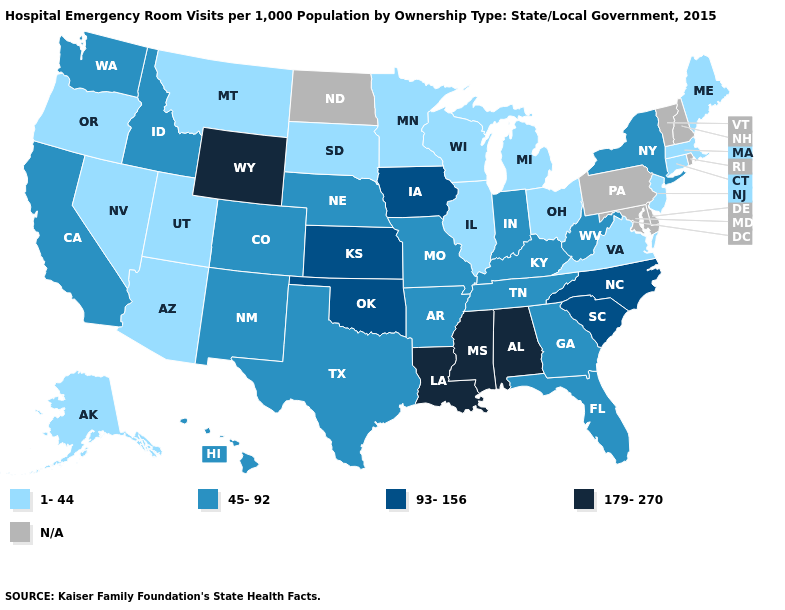Among the states that border Pennsylvania , does West Virginia have the lowest value?
Short answer required. No. Among the states that border Montana , does South Dakota have the lowest value?
Concise answer only. Yes. Name the states that have a value in the range 93-156?
Concise answer only. Iowa, Kansas, North Carolina, Oklahoma, South Carolina. Name the states that have a value in the range 179-270?
Keep it brief. Alabama, Louisiana, Mississippi, Wyoming. Does Wyoming have the highest value in the West?
Answer briefly. Yes. Name the states that have a value in the range N/A?
Short answer required. Delaware, Maryland, New Hampshire, North Dakota, Pennsylvania, Rhode Island, Vermont. Name the states that have a value in the range 45-92?
Give a very brief answer. Arkansas, California, Colorado, Florida, Georgia, Hawaii, Idaho, Indiana, Kentucky, Missouri, Nebraska, New Mexico, New York, Tennessee, Texas, Washington, West Virginia. Does West Virginia have the lowest value in the South?
Write a very short answer. No. Does Wyoming have the highest value in the USA?
Quick response, please. Yes. What is the value of Iowa?
Short answer required. 93-156. What is the lowest value in the South?
Be succinct. 1-44. Name the states that have a value in the range 93-156?
Be succinct. Iowa, Kansas, North Carolina, Oklahoma, South Carolina. What is the highest value in the South ?
Answer briefly. 179-270. Name the states that have a value in the range 1-44?
Keep it brief. Alaska, Arizona, Connecticut, Illinois, Maine, Massachusetts, Michigan, Minnesota, Montana, Nevada, New Jersey, Ohio, Oregon, South Dakota, Utah, Virginia, Wisconsin. Does Oklahoma have the highest value in the USA?
Give a very brief answer. No. 